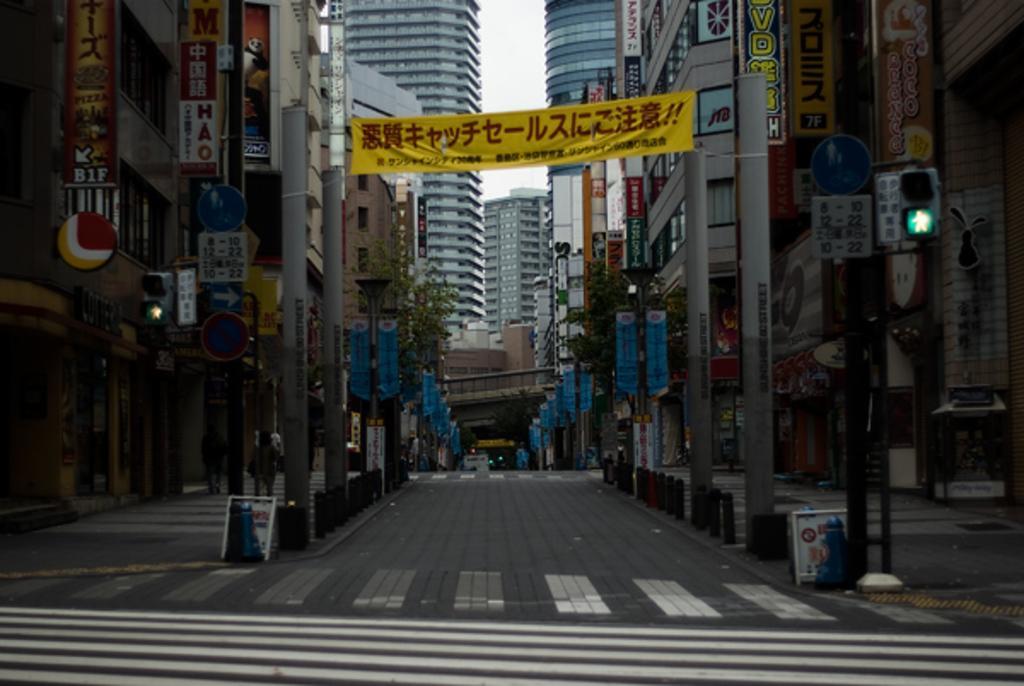Can you describe this image briefly? This image is taken outdoors. At the bottom of the image there is a road. In the middle of the image there are many buildings. There are a few trees. There are a few poles with street lights. There are a few sign boards. There are many boards with text on them and there are a few banners with text on them. 